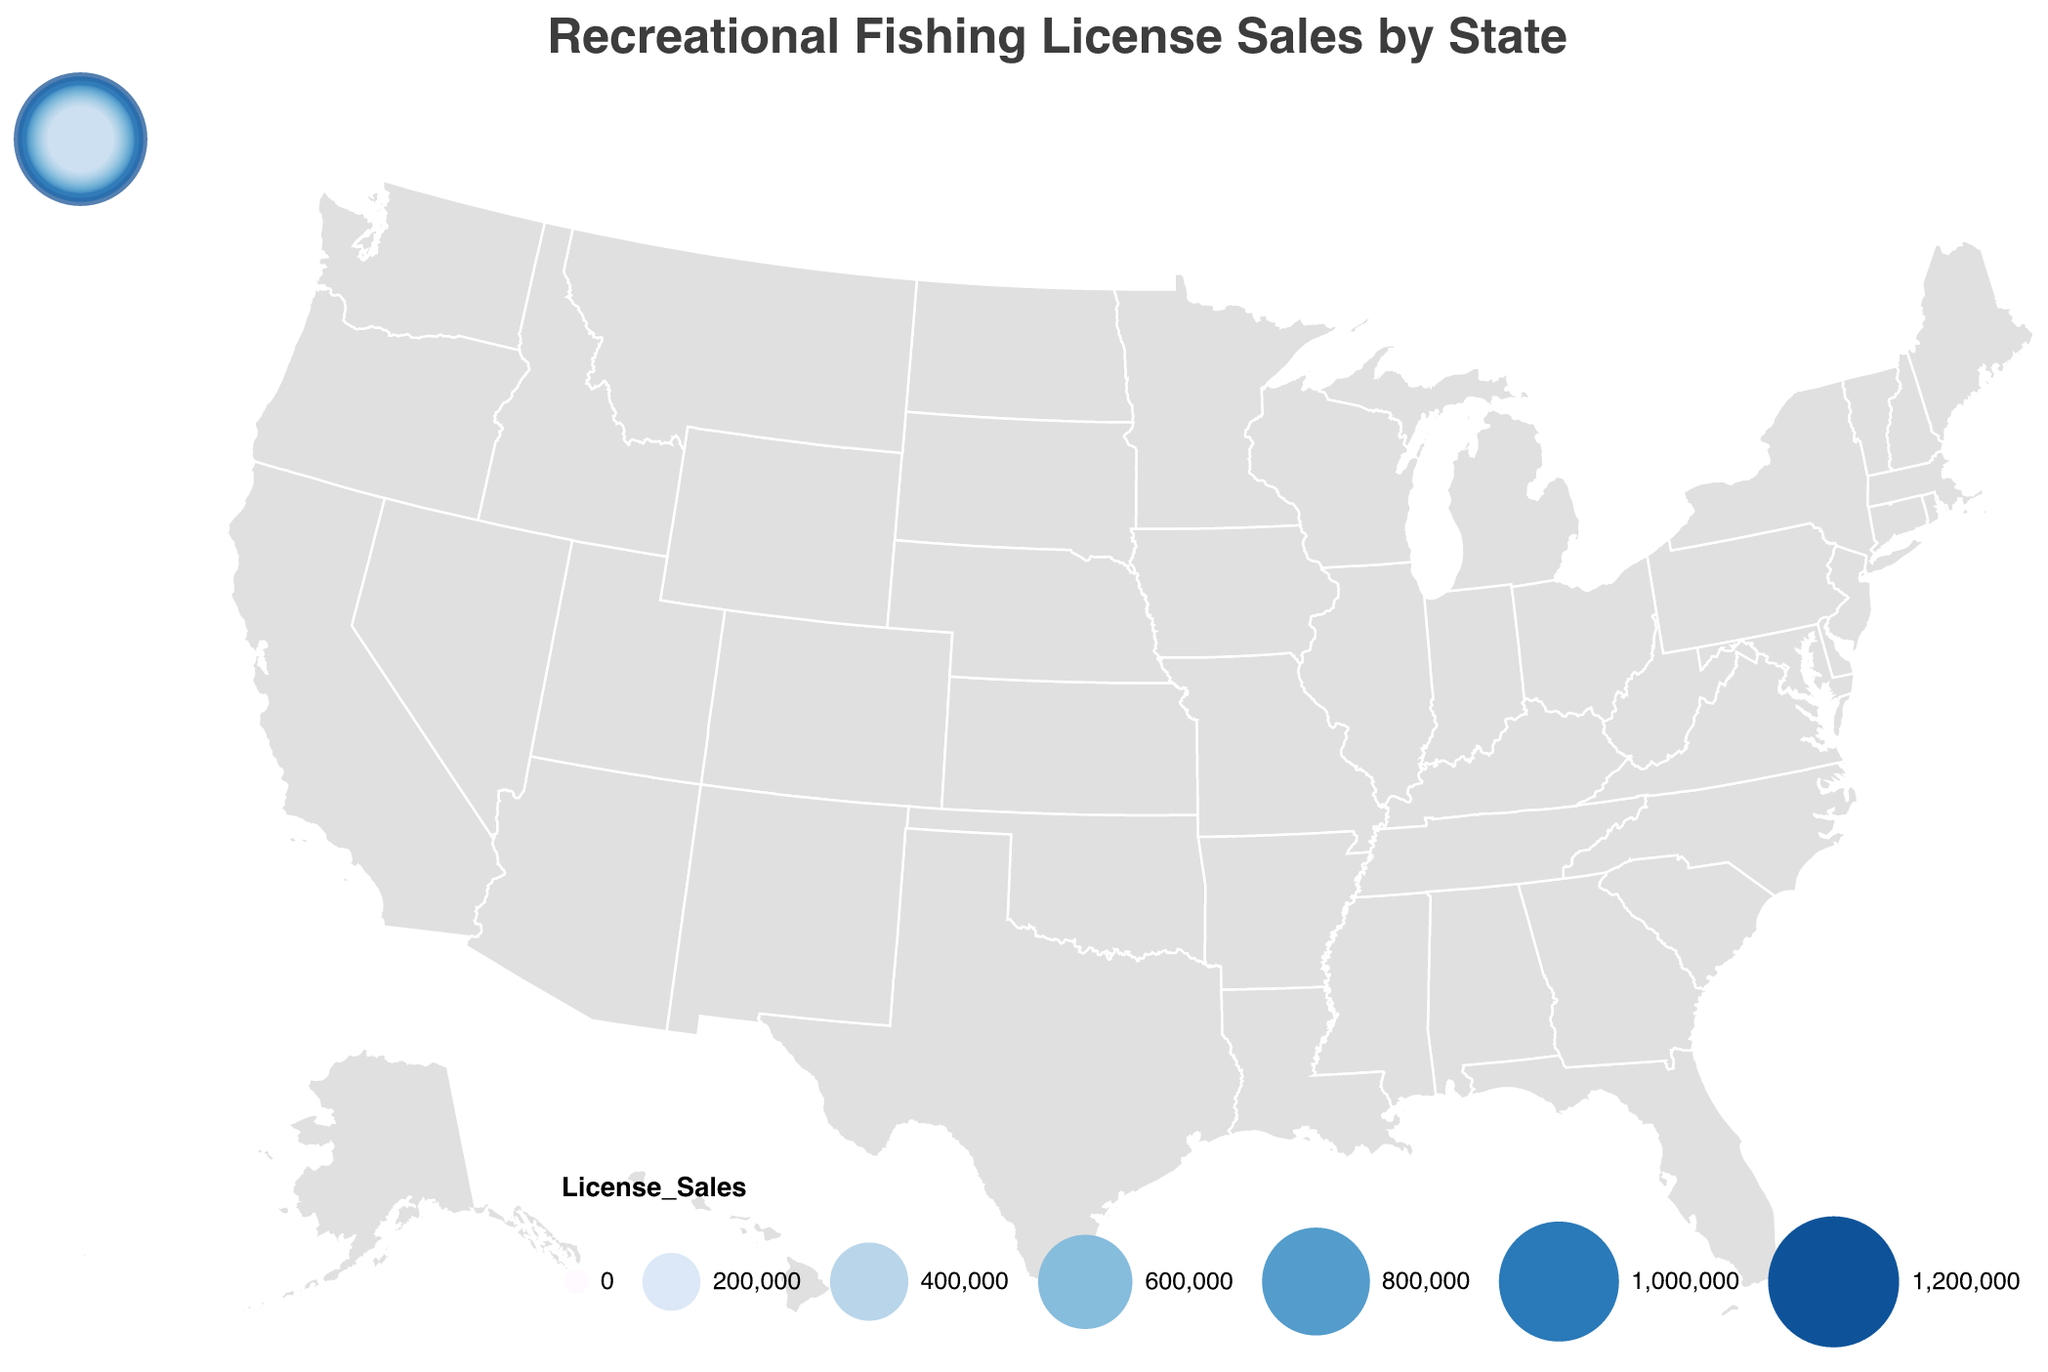What is the title of the figure? The title of the figure is usually displayed at the top. In this case, it reads "Recreational Fishing License Sales by State."
Answer: Recreational Fishing License Sales by State What is the state with the highest fishing license sales? The state with the largest circle and the darkest blue color represents the highest sales. In this figure, it is California with 1,250,000 sales.
Answer: California How do Florida and Texas compare in terms of fishing license sales? We need to compare the sizes and colors of the circles for Florida and Texas. Florida has 1,100,000 sales while Texas has 950,000 sales, meaning Florida has higher sales.
Answer: Florida has higher sales than Texas What is the total fishing license sales for the top three states combined? To find the total sales for the top three states, add the sales of California, Florida, and Texas. The total is 1,250,000 (California) + 1,100,000 (Florida) + 950,000 (Texas) = 3,300,000.
Answer: 3,300,000 Which state has the lowest fishing license sales? The state with the smallest circle and the lightest blue color represents the lowest sales. In this figure, it is Washington with 275,000 sales.
Answer: Washington What is the median value of fishing license sales across all states? To find the median, we need to first list all the sales values in ascending order and then find the middle value. The sorted list of sales values is 275,000, 300,000, 350,000, 400,000, 450,000, 500,000, 550,000, 600,000, 650,000, 700,000, 750,000, 800,000, 950,000, 1,100,000, 1,250,000. The median value (the 8th and 9th values averaged) is (600,000 + 650,000) / 2 = 625,000.
Answer: 625,000 Which region of the United States has the densest concentration of states with high fishing license sales? By observing the geographic distribution and clustering of dark blue and large circles, the Southeastern region (Florida, Georgia, North Carolina) and the Midwest (Michigan, Wisconsin, Minnesota) show a high concentration of states with significant fishing license sales.
Answer: Southeastern and Midwest How does the color scheme help in interpreting the fishing license sales? The color scheme uses shades of blue where darker shades indicate higher sales and lighter shades indicate lower sales, assisting in quickly identifying states with high and low sales.
Answer: Darker blue indicates higher sales What is the average fishing license sales for all states? To calculate the average, sum all sales and divide by the number of states. The total sales are 9,175,000, and there are 15 states, so the average is 9,175,000 / 15 ≈ 611,667.
Answer: 611,667 